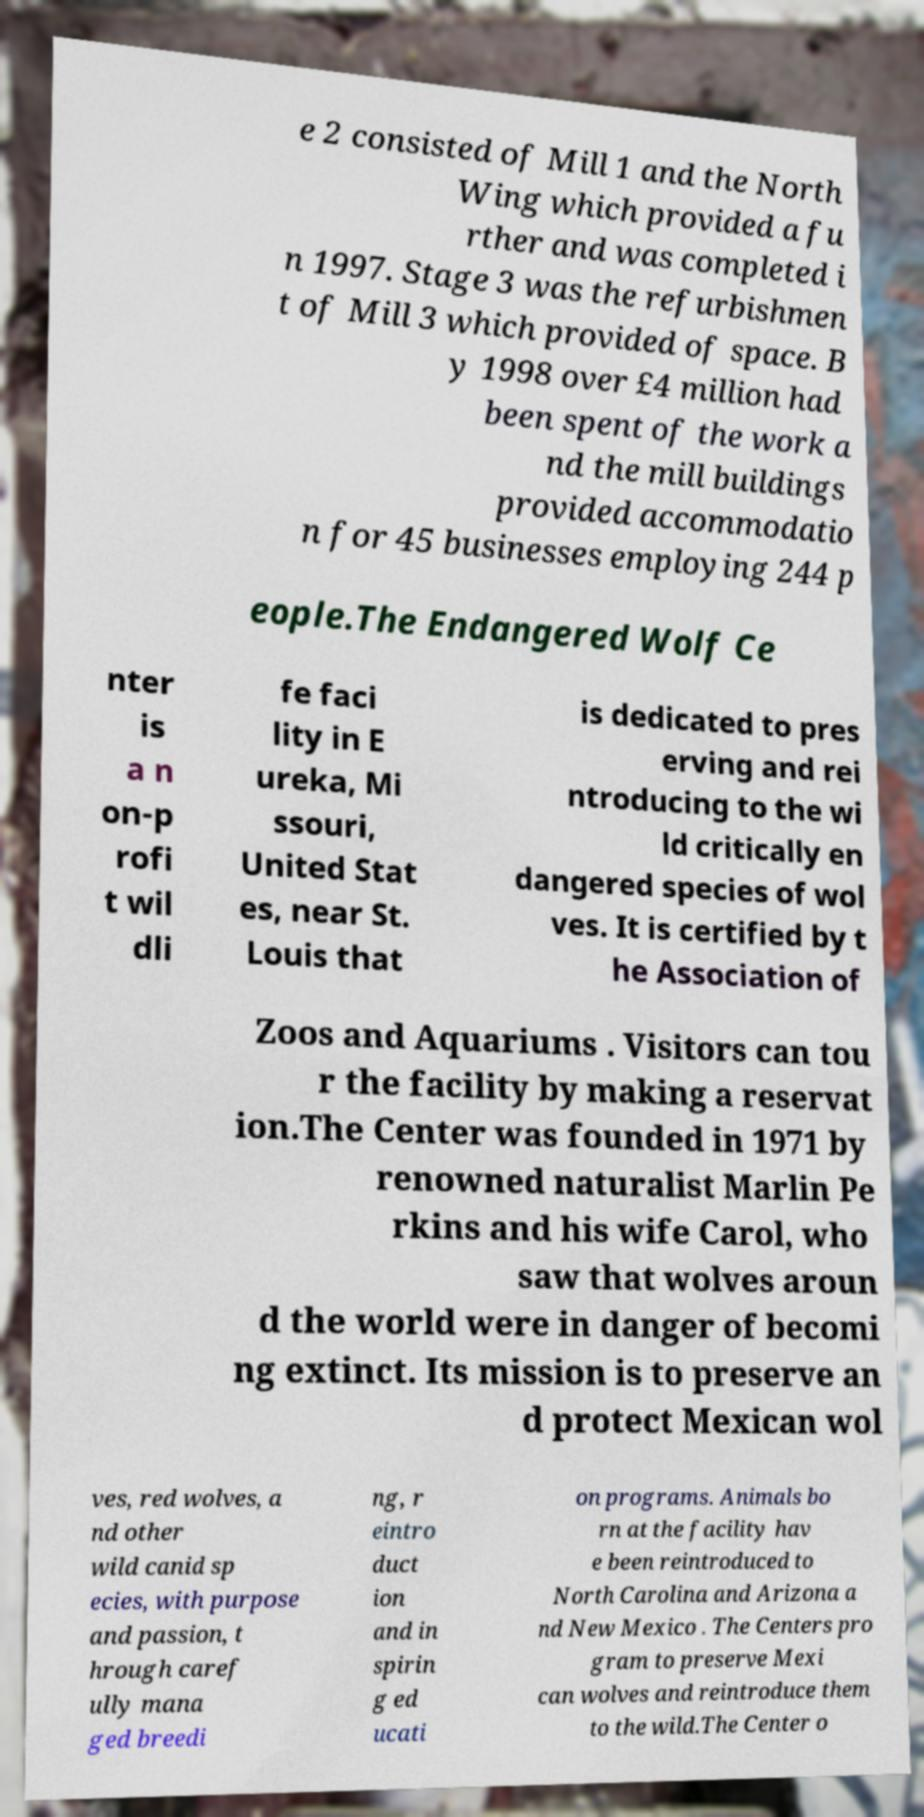Please read and relay the text visible in this image. What does it say? e 2 consisted of Mill 1 and the North Wing which provided a fu rther and was completed i n 1997. Stage 3 was the refurbishmen t of Mill 3 which provided of space. B y 1998 over £4 million had been spent of the work a nd the mill buildings provided accommodatio n for 45 businesses employing 244 p eople.The Endangered Wolf Ce nter is a n on-p rofi t wil dli fe faci lity in E ureka, Mi ssouri, United Stat es, near St. Louis that is dedicated to pres erving and rei ntroducing to the wi ld critically en dangered species of wol ves. It is certified by t he Association of Zoos and Aquariums . Visitors can tou r the facility by making a reservat ion.The Center was founded in 1971 by renowned naturalist Marlin Pe rkins and his wife Carol, who saw that wolves aroun d the world were in danger of becomi ng extinct. Its mission is to preserve an d protect Mexican wol ves, red wolves, a nd other wild canid sp ecies, with purpose and passion, t hrough caref ully mana ged breedi ng, r eintro duct ion and in spirin g ed ucati on programs. Animals bo rn at the facility hav e been reintroduced to North Carolina and Arizona a nd New Mexico . The Centers pro gram to preserve Mexi can wolves and reintroduce them to the wild.The Center o 